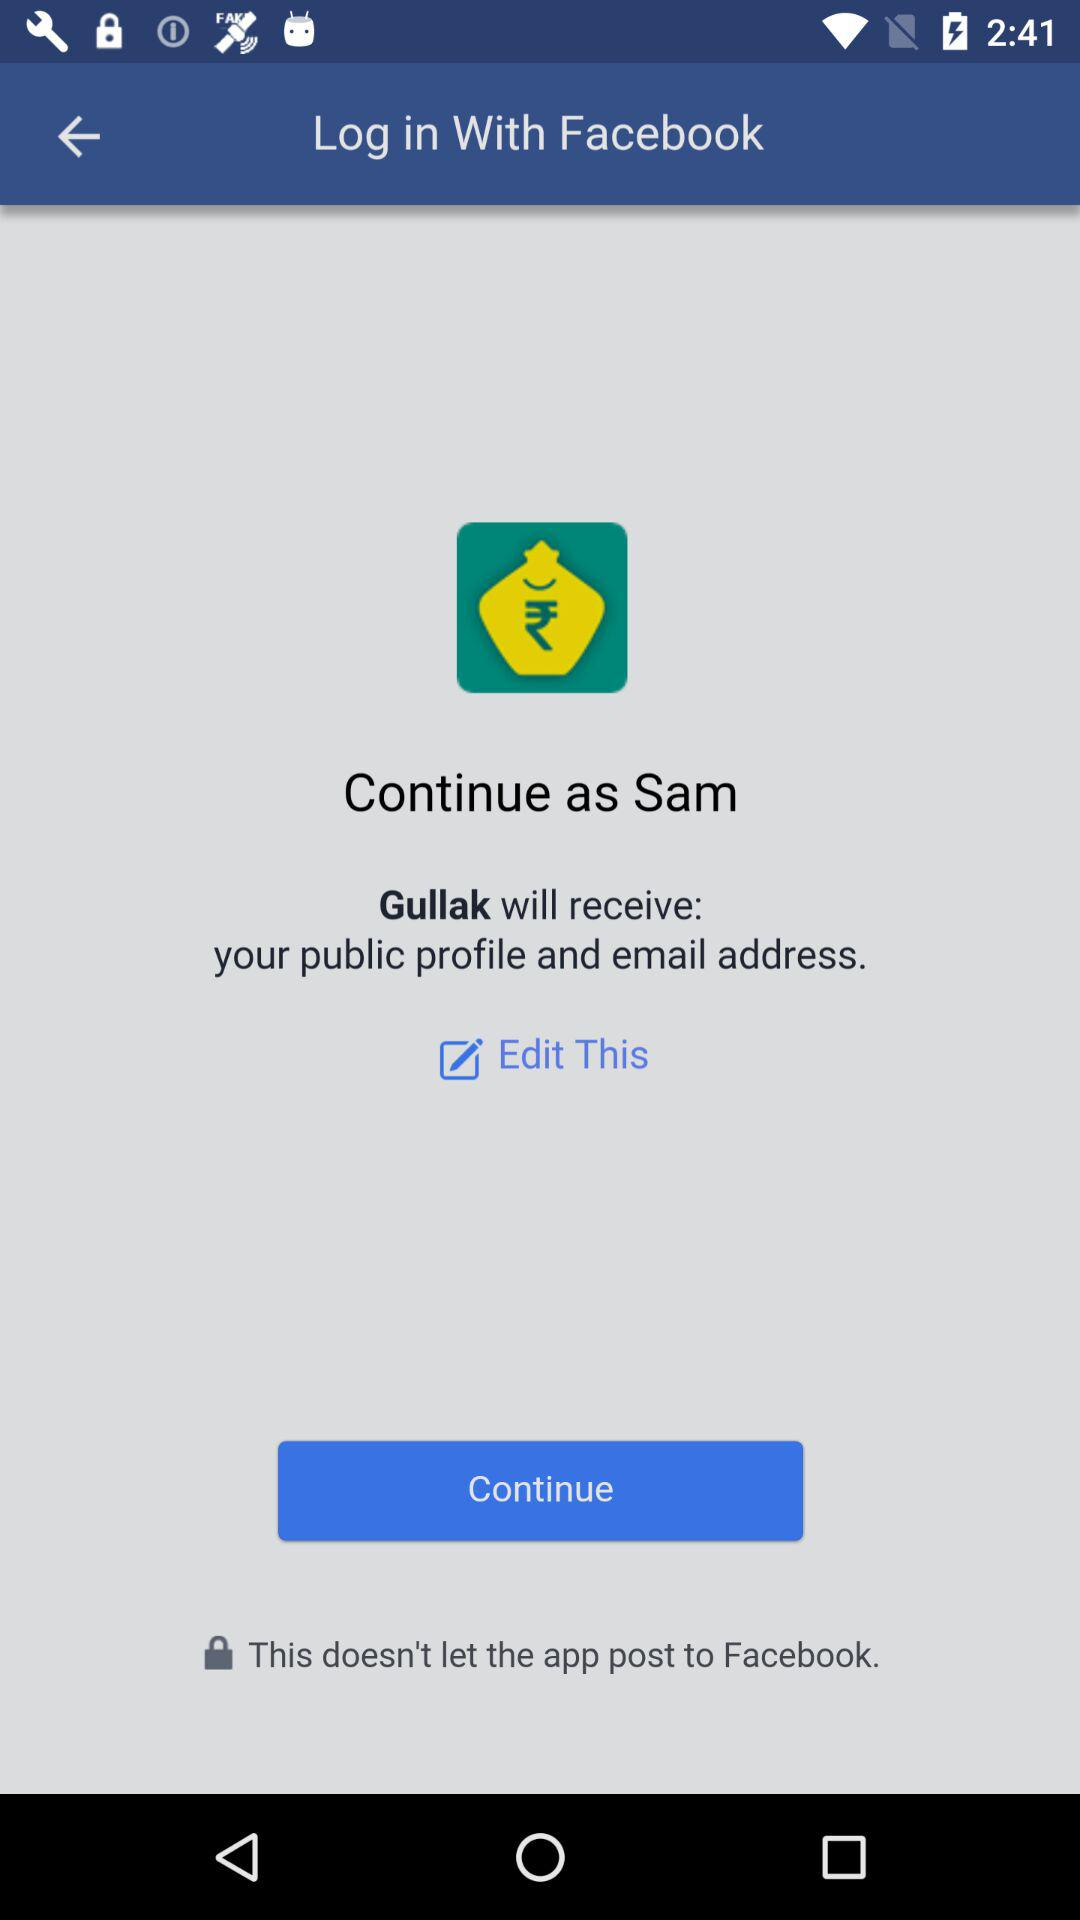What application is asking for permission? The application is "Gullak". 